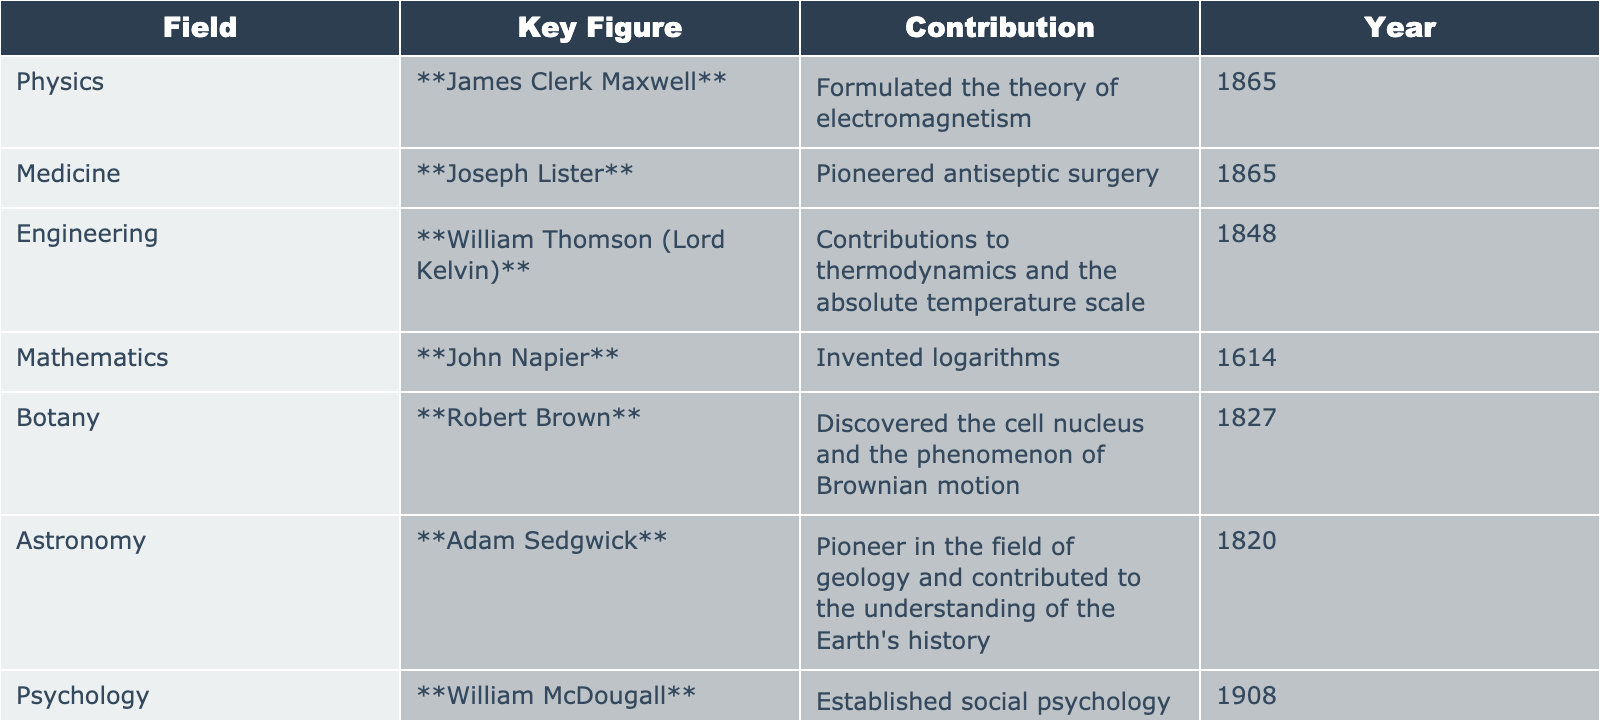What was James Clerk Maxwell's contribution to science? According to the table, James Clerk Maxwell formulated the theory of electromagnetism in 1865.
Answer: Formulated the theory of electromagnetism Who pioneered antiseptic surgery and in what year? The table shows that Joseph Lister pioneered antiseptic surgery in the year 1865.
Answer: Joseph Lister, 1865 Which field did William Thomson (Lord Kelvin) contribute to? By checking the table, William Thomson (Lord Kelvin) is noted for his contributions in engineering, specifically to thermodynamics and the absolute temperature scale.
Answer: Engineering What significant mathematical concept did John Napier invent? The table states that John Napier invented logarithms, which is a significant concept in mathematics.
Answer: Logarithms Who discovered the phenomenon of Brownian motion? According to the table, Robert Brown is credited with discovering the phenomenon of Brownian motion and the cell nucleus.
Answer: Robert Brown In which year did Sir Archibald Geikie make his contributions to geology? The table indicates that Sir Archibald Geikie developed modern concepts in geology in 1880.
Answer: 1880 Which key figure is associated with the advancement of psychology? From the table, William McDougall is identified as the key figure who established social psychology as a distinct field.
Answer: William McDougall What is the average year of contributions made by the figures listed in the Medicine field? The relevant figures in Medicine are Joseph Lister (1865). The average is the total years (1865) divided by the number of contributions (1), which is 1865.
Answer: 1865 True or False: Adam Sedgwick contributed to the field of botany. The table indicates that Adam Sedgwick's contributions were primarily in the field of geology, not botany.
Answer: False Which two fields made their advancements in the same year? The table shows that both James Clerk Maxwell and Joseph Lister made their contributions in the year 1865.
Answer: Physics and Medicine in 1865 What is the difference in years between the contributions of John Napier and William Thomson (Lord Kelvin)? John Napier made his contribution in 1614, while William Thomson made his in 1848. The difference is 1848 - 1614 = 234 years.
Answer: 234 years 